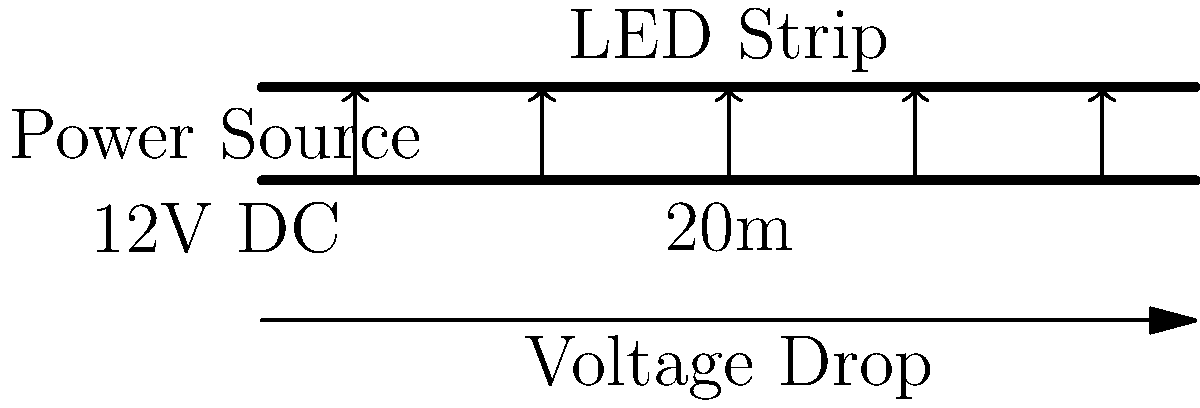For a minimalist architectural installation, you're planning to backlight a large silk fabric panel with LED strips. The installation requires a 20-meter run of 22 AWG wire to connect a 12V DC power source to the LED strip. If the LED strip draws 2A of current, what is the voltage drop along the wire, and what voltage will be available at the LED strip? Assume the resistivity of copper is $1.68 \times 10^{-8} \, \Omega \cdot m$ and the cross-sectional area of 22 AWG wire is $0.326 \, mm^2$. To solve this problem, we'll use the voltage drop formula and Ohm's law:

1. Calculate the resistance of the wire:
   $R = \rho \frac{L}{A}$
   Where:
   $\rho$ = resistivity of copper = $1.68 \times 10^{-8} \, \Omega \cdot m$
   $L$ = length of wire = $20 \, m$ (note: multiply by 2 for round trip)
   $A$ = cross-sectional area = $0.326 \times 10^{-6} \, m^2$

   $R = 1.68 \times 10^{-8} \cdot \frac{2 \cdot 20}{0.326 \times 10^{-6}} = 2.06 \, \Omega$

2. Calculate the voltage drop using Ohm's law:
   $V_{drop} = I \cdot R$
   Where:
   $I$ = current = $2 \, A$
   $R$ = resistance = $2.06 \, \Omega$

   $V_{drop} = 2 \cdot 2.06 = 4.12 \, V$

3. Calculate the voltage available at the LED strip:
   $V_{LED} = V_{source} - V_{drop}$
   $V_{LED} = 12 - 4.12 = 7.88 \, V$
Answer: Voltage drop: 4.12V; Available voltage at LED strip: 7.88V 